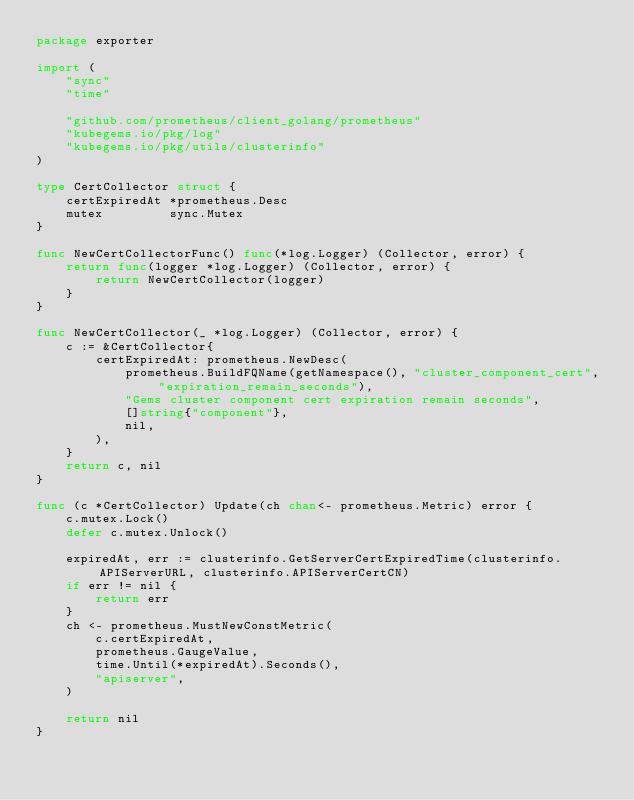Convert code to text. <code><loc_0><loc_0><loc_500><loc_500><_Go_>package exporter

import (
	"sync"
	"time"

	"github.com/prometheus/client_golang/prometheus"
	"kubegems.io/pkg/log"
	"kubegems.io/pkg/utils/clusterinfo"
)

type CertCollector struct {
	certExpiredAt *prometheus.Desc
	mutex         sync.Mutex
}

func NewCertCollectorFunc() func(*log.Logger) (Collector, error) {
	return func(logger *log.Logger) (Collector, error) {
		return NewCertCollector(logger)
	}
}

func NewCertCollector(_ *log.Logger) (Collector, error) {
	c := &CertCollector{
		certExpiredAt: prometheus.NewDesc(
			prometheus.BuildFQName(getNamespace(), "cluster_component_cert", "expiration_remain_seconds"),
			"Gems cluster component cert expiration remain seconds",
			[]string{"component"},
			nil,
		),
	}
	return c, nil
}

func (c *CertCollector) Update(ch chan<- prometheus.Metric) error {
	c.mutex.Lock()
	defer c.mutex.Unlock()

	expiredAt, err := clusterinfo.GetServerCertExpiredTime(clusterinfo.APIServerURL, clusterinfo.APIServerCertCN)
	if err != nil {
		return err
	}
	ch <- prometheus.MustNewConstMetric(
		c.certExpiredAt,
		prometheus.GaugeValue,
		time.Until(*expiredAt).Seconds(),
		"apiserver",
	)

	return nil
}
</code> 